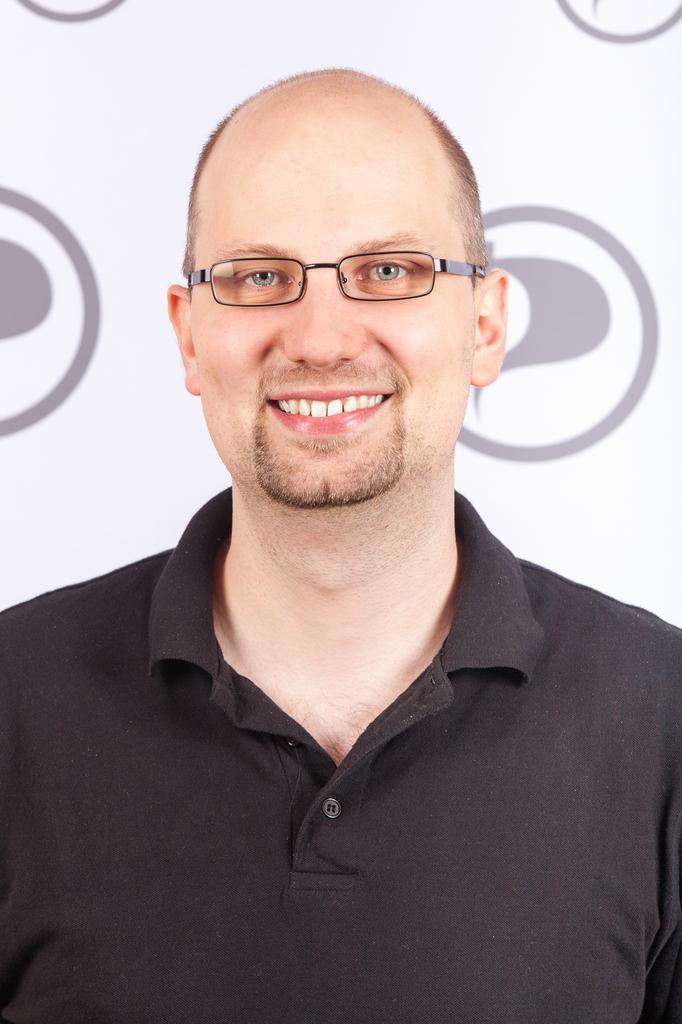In one or two sentences, can you explain what this image depicts? In this picture we can see a man wore spectacles and smiling and at the back of him we can see a banner. 